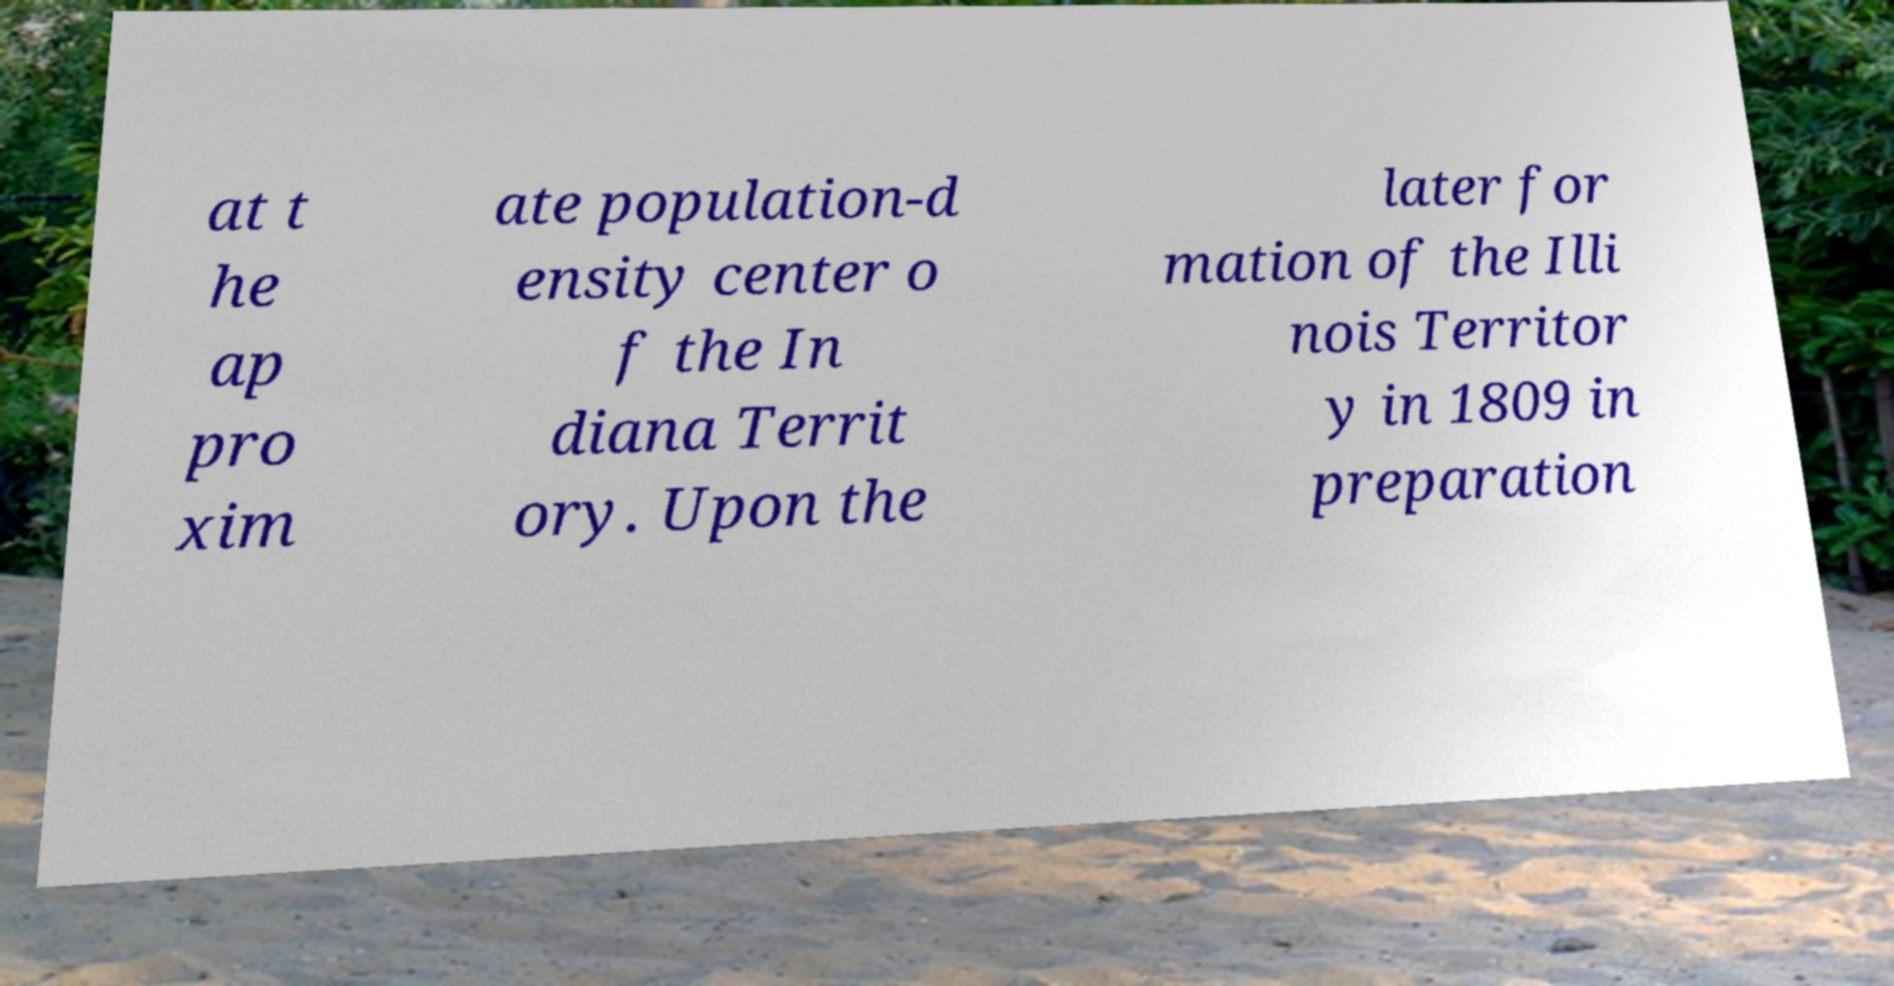What messages or text are displayed in this image? I need them in a readable, typed format. at t he ap pro xim ate population-d ensity center o f the In diana Territ ory. Upon the later for mation of the Illi nois Territor y in 1809 in preparation 